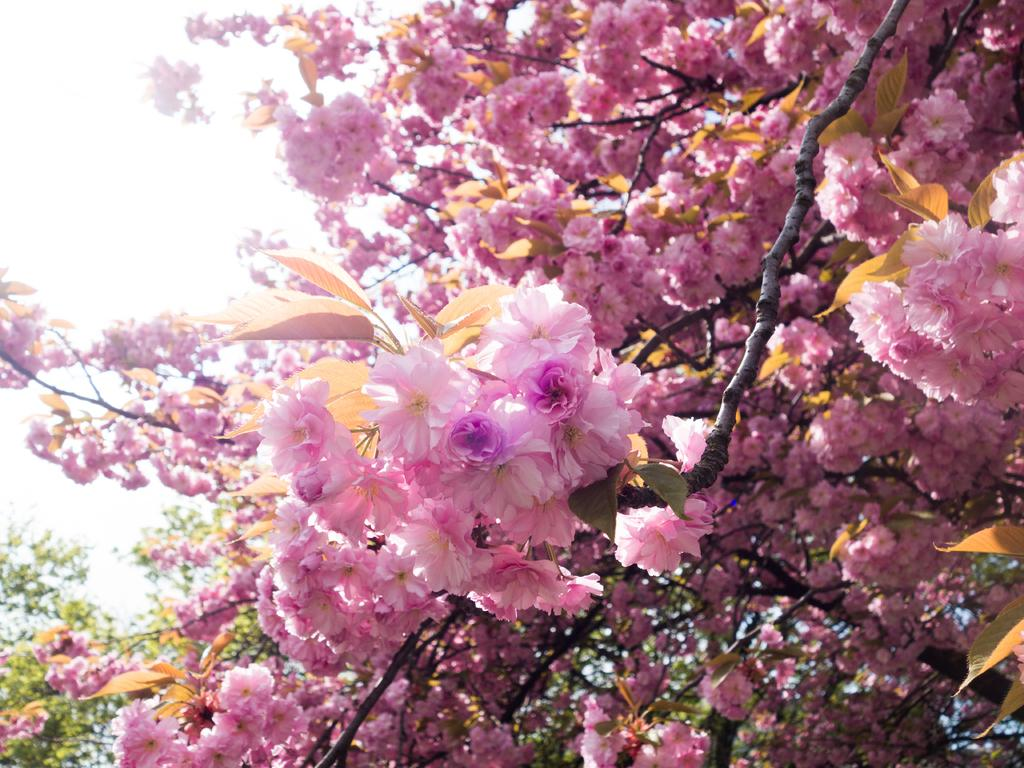What is present on the branches of the tree in the image? There is a group of flowers on the branches of a tree. What can be seen in the background of the image? The sky is visible in the background of the image. How many legs can be seen on the flowers in the image? Flowers do not have legs, so this question cannot be answered based on the image. 